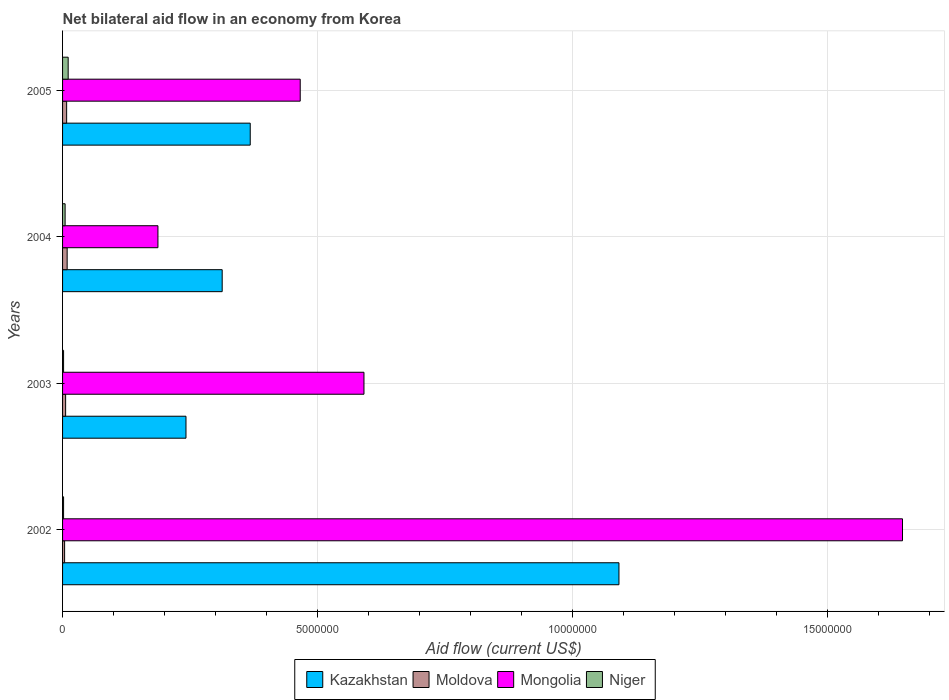How many different coloured bars are there?
Give a very brief answer. 4. How many groups of bars are there?
Offer a very short reply. 4. Across all years, what is the maximum net bilateral aid flow in Moldova?
Your answer should be compact. 9.00e+04. Across all years, what is the minimum net bilateral aid flow in Mongolia?
Offer a very short reply. 1.87e+06. What is the total net bilateral aid flow in Kazakhstan in the graph?
Provide a succinct answer. 2.01e+07. What is the difference between the net bilateral aid flow in Niger in 2003 and that in 2005?
Keep it short and to the point. -9.00e+04. What is the difference between the net bilateral aid flow in Niger in 2003 and the net bilateral aid flow in Kazakhstan in 2002?
Your response must be concise. -1.09e+07. What is the average net bilateral aid flow in Kazakhstan per year?
Provide a short and direct response. 5.04e+06. In the year 2005, what is the difference between the net bilateral aid flow in Niger and net bilateral aid flow in Kazakhstan?
Your response must be concise. -3.57e+06. What is the ratio of the net bilateral aid flow in Mongolia in 2002 to that in 2004?
Keep it short and to the point. 8.81. Is the net bilateral aid flow in Kazakhstan in 2004 less than that in 2005?
Your response must be concise. Yes. Is the difference between the net bilateral aid flow in Niger in 2003 and 2005 greater than the difference between the net bilateral aid flow in Kazakhstan in 2003 and 2005?
Provide a succinct answer. Yes. What is the difference between the highest and the second highest net bilateral aid flow in Moldova?
Provide a succinct answer. 10000. What is the difference between the highest and the lowest net bilateral aid flow in Mongolia?
Give a very brief answer. 1.46e+07. In how many years, is the net bilateral aid flow in Kazakhstan greater than the average net bilateral aid flow in Kazakhstan taken over all years?
Provide a short and direct response. 1. Is the sum of the net bilateral aid flow in Moldova in 2004 and 2005 greater than the maximum net bilateral aid flow in Kazakhstan across all years?
Give a very brief answer. No. Is it the case that in every year, the sum of the net bilateral aid flow in Moldova and net bilateral aid flow in Niger is greater than the sum of net bilateral aid flow in Mongolia and net bilateral aid flow in Kazakhstan?
Provide a succinct answer. No. What does the 1st bar from the top in 2003 represents?
Make the answer very short. Niger. What does the 1st bar from the bottom in 2002 represents?
Your answer should be very brief. Kazakhstan. How many bars are there?
Offer a terse response. 16. Are all the bars in the graph horizontal?
Your answer should be very brief. Yes. How many years are there in the graph?
Provide a succinct answer. 4. Are the values on the major ticks of X-axis written in scientific E-notation?
Provide a succinct answer. No. Does the graph contain grids?
Your answer should be very brief. Yes. How many legend labels are there?
Offer a terse response. 4. How are the legend labels stacked?
Your answer should be very brief. Horizontal. What is the title of the graph?
Make the answer very short. Net bilateral aid flow in an economy from Korea. Does "Iraq" appear as one of the legend labels in the graph?
Ensure brevity in your answer.  No. What is the Aid flow (current US$) of Kazakhstan in 2002?
Provide a short and direct response. 1.09e+07. What is the Aid flow (current US$) of Moldova in 2002?
Your response must be concise. 4.00e+04. What is the Aid flow (current US$) of Mongolia in 2002?
Your response must be concise. 1.65e+07. What is the Aid flow (current US$) in Niger in 2002?
Give a very brief answer. 2.00e+04. What is the Aid flow (current US$) of Kazakhstan in 2003?
Make the answer very short. 2.42e+06. What is the Aid flow (current US$) in Moldova in 2003?
Ensure brevity in your answer.  6.00e+04. What is the Aid flow (current US$) of Mongolia in 2003?
Offer a terse response. 5.91e+06. What is the Aid flow (current US$) of Niger in 2003?
Make the answer very short. 2.00e+04. What is the Aid flow (current US$) in Kazakhstan in 2004?
Make the answer very short. 3.13e+06. What is the Aid flow (current US$) in Mongolia in 2004?
Offer a very short reply. 1.87e+06. What is the Aid flow (current US$) in Niger in 2004?
Give a very brief answer. 5.00e+04. What is the Aid flow (current US$) of Kazakhstan in 2005?
Your response must be concise. 3.68e+06. What is the Aid flow (current US$) of Moldova in 2005?
Your answer should be very brief. 8.00e+04. What is the Aid flow (current US$) of Mongolia in 2005?
Make the answer very short. 4.66e+06. Across all years, what is the maximum Aid flow (current US$) in Kazakhstan?
Your answer should be compact. 1.09e+07. Across all years, what is the maximum Aid flow (current US$) of Moldova?
Keep it short and to the point. 9.00e+04. Across all years, what is the maximum Aid flow (current US$) of Mongolia?
Your response must be concise. 1.65e+07. Across all years, what is the maximum Aid flow (current US$) in Niger?
Offer a terse response. 1.10e+05. Across all years, what is the minimum Aid flow (current US$) in Kazakhstan?
Give a very brief answer. 2.42e+06. Across all years, what is the minimum Aid flow (current US$) in Mongolia?
Your response must be concise. 1.87e+06. Across all years, what is the minimum Aid flow (current US$) of Niger?
Your answer should be very brief. 2.00e+04. What is the total Aid flow (current US$) of Kazakhstan in the graph?
Ensure brevity in your answer.  2.01e+07. What is the total Aid flow (current US$) of Moldova in the graph?
Your response must be concise. 2.70e+05. What is the total Aid flow (current US$) of Mongolia in the graph?
Ensure brevity in your answer.  2.89e+07. What is the difference between the Aid flow (current US$) of Kazakhstan in 2002 and that in 2003?
Provide a succinct answer. 8.49e+06. What is the difference between the Aid flow (current US$) in Mongolia in 2002 and that in 2003?
Your answer should be very brief. 1.06e+07. What is the difference between the Aid flow (current US$) in Niger in 2002 and that in 2003?
Your response must be concise. 0. What is the difference between the Aid flow (current US$) in Kazakhstan in 2002 and that in 2004?
Your response must be concise. 7.78e+06. What is the difference between the Aid flow (current US$) of Moldova in 2002 and that in 2004?
Your response must be concise. -5.00e+04. What is the difference between the Aid flow (current US$) in Mongolia in 2002 and that in 2004?
Provide a short and direct response. 1.46e+07. What is the difference between the Aid flow (current US$) of Niger in 2002 and that in 2004?
Ensure brevity in your answer.  -3.00e+04. What is the difference between the Aid flow (current US$) in Kazakhstan in 2002 and that in 2005?
Your answer should be very brief. 7.23e+06. What is the difference between the Aid flow (current US$) of Mongolia in 2002 and that in 2005?
Provide a succinct answer. 1.18e+07. What is the difference between the Aid flow (current US$) in Niger in 2002 and that in 2005?
Provide a succinct answer. -9.00e+04. What is the difference between the Aid flow (current US$) in Kazakhstan in 2003 and that in 2004?
Offer a very short reply. -7.10e+05. What is the difference between the Aid flow (current US$) in Mongolia in 2003 and that in 2004?
Provide a short and direct response. 4.04e+06. What is the difference between the Aid flow (current US$) in Kazakhstan in 2003 and that in 2005?
Keep it short and to the point. -1.26e+06. What is the difference between the Aid flow (current US$) of Mongolia in 2003 and that in 2005?
Your answer should be very brief. 1.25e+06. What is the difference between the Aid flow (current US$) of Kazakhstan in 2004 and that in 2005?
Your answer should be compact. -5.50e+05. What is the difference between the Aid flow (current US$) in Mongolia in 2004 and that in 2005?
Provide a short and direct response. -2.79e+06. What is the difference between the Aid flow (current US$) of Niger in 2004 and that in 2005?
Offer a terse response. -6.00e+04. What is the difference between the Aid flow (current US$) of Kazakhstan in 2002 and the Aid flow (current US$) of Moldova in 2003?
Ensure brevity in your answer.  1.08e+07. What is the difference between the Aid flow (current US$) in Kazakhstan in 2002 and the Aid flow (current US$) in Mongolia in 2003?
Provide a short and direct response. 5.00e+06. What is the difference between the Aid flow (current US$) in Kazakhstan in 2002 and the Aid flow (current US$) in Niger in 2003?
Offer a very short reply. 1.09e+07. What is the difference between the Aid flow (current US$) of Moldova in 2002 and the Aid flow (current US$) of Mongolia in 2003?
Offer a very short reply. -5.87e+06. What is the difference between the Aid flow (current US$) in Mongolia in 2002 and the Aid flow (current US$) in Niger in 2003?
Give a very brief answer. 1.64e+07. What is the difference between the Aid flow (current US$) of Kazakhstan in 2002 and the Aid flow (current US$) of Moldova in 2004?
Ensure brevity in your answer.  1.08e+07. What is the difference between the Aid flow (current US$) in Kazakhstan in 2002 and the Aid flow (current US$) in Mongolia in 2004?
Provide a short and direct response. 9.04e+06. What is the difference between the Aid flow (current US$) of Kazakhstan in 2002 and the Aid flow (current US$) of Niger in 2004?
Provide a succinct answer. 1.09e+07. What is the difference between the Aid flow (current US$) in Moldova in 2002 and the Aid flow (current US$) in Mongolia in 2004?
Offer a terse response. -1.83e+06. What is the difference between the Aid flow (current US$) in Mongolia in 2002 and the Aid flow (current US$) in Niger in 2004?
Your answer should be very brief. 1.64e+07. What is the difference between the Aid flow (current US$) of Kazakhstan in 2002 and the Aid flow (current US$) of Moldova in 2005?
Your answer should be compact. 1.08e+07. What is the difference between the Aid flow (current US$) in Kazakhstan in 2002 and the Aid flow (current US$) in Mongolia in 2005?
Ensure brevity in your answer.  6.25e+06. What is the difference between the Aid flow (current US$) of Kazakhstan in 2002 and the Aid flow (current US$) of Niger in 2005?
Provide a short and direct response. 1.08e+07. What is the difference between the Aid flow (current US$) of Moldova in 2002 and the Aid flow (current US$) of Mongolia in 2005?
Provide a succinct answer. -4.62e+06. What is the difference between the Aid flow (current US$) in Mongolia in 2002 and the Aid flow (current US$) in Niger in 2005?
Offer a terse response. 1.64e+07. What is the difference between the Aid flow (current US$) in Kazakhstan in 2003 and the Aid flow (current US$) in Moldova in 2004?
Keep it short and to the point. 2.33e+06. What is the difference between the Aid flow (current US$) of Kazakhstan in 2003 and the Aid flow (current US$) of Niger in 2004?
Your answer should be compact. 2.37e+06. What is the difference between the Aid flow (current US$) of Moldova in 2003 and the Aid flow (current US$) of Mongolia in 2004?
Provide a succinct answer. -1.81e+06. What is the difference between the Aid flow (current US$) in Moldova in 2003 and the Aid flow (current US$) in Niger in 2004?
Your answer should be very brief. 10000. What is the difference between the Aid flow (current US$) of Mongolia in 2003 and the Aid flow (current US$) of Niger in 2004?
Give a very brief answer. 5.86e+06. What is the difference between the Aid flow (current US$) in Kazakhstan in 2003 and the Aid flow (current US$) in Moldova in 2005?
Your answer should be compact. 2.34e+06. What is the difference between the Aid flow (current US$) of Kazakhstan in 2003 and the Aid flow (current US$) of Mongolia in 2005?
Your answer should be very brief. -2.24e+06. What is the difference between the Aid flow (current US$) of Kazakhstan in 2003 and the Aid flow (current US$) of Niger in 2005?
Make the answer very short. 2.31e+06. What is the difference between the Aid flow (current US$) of Moldova in 2003 and the Aid flow (current US$) of Mongolia in 2005?
Offer a terse response. -4.60e+06. What is the difference between the Aid flow (current US$) in Mongolia in 2003 and the Aid flow (current US$) in Niger in 2005?
Provide a succinct answer. 5.80e+06. What is the difference between the Aid flow (current US$) of Kazakhstan in 2004 and the Aid flow (current US$) of Moldova in 2005?
Give a very brief answer. 3.05e+06. What is the difference between the Aid flow (current US$) in Kazakhstan in 2004 and the Aid flow (current US$) in Mongolia in 2005?
Your response must be concise. -1.53e+06. What is the difference between the Aid flow (current US$) in Kazakhstan in 2004 and the Aid flow (current US$) in Niger in 2005?
Make the answer very short. 3.02e+06. What is the difference between the Aid flow (current US$) in Moldova in 2004 and the Aid flow (current US$) in Mongolia in 2005?
Ensure brevity in your answer.  -4.57e+06. What is the difference between the Aid flow (current US$) of Moldova in 2004 and the Aid flow (current US$) of Niger in 2005?
Provide a succinct answer. -2.00e+04. What is the difference between the Aid flow (current US$) of Mongolia in 2004 and the Aid flow (current US$) of Niger in 2005?
Make the answer very short. 1.76e+06. What is the average Aid flow (current US$) of Kazakhstan per year?
Make the answer very short. 5.04e+06. What is the average Aid flow (current US$) of Moldova per year?
Your response must be concise. 6.75e+04. What is the average Aid flow (current US$) in Mongolia per year?
Your answer should be very brief. 7.23e+06. What is the average Aid flow (current US$) in Niger per year?
Your response must be concise. 5.00e+04. In the year 2002, what is the difference between the Aid flow (current US$) of Kazakhstan and Aid flow (current US$) of Moldova?
Provide a succinct answer. 1.09e+07. In the year 2002, what is the difference between the Aid flow (current US$) of Kazakhstan and Aid flow (current US$) of Mongolia?
Provide a short and direct response. -5.56e+06. In the year 2002, what is the difference between the Aid flow (current US$) of Kazakhstan and Aid flow (current US$) of Niger?
Give a very brief answer. 1.09e+07. In the year 2002, what is the difference between the Aid flow (current US$) in Moldova and Aid flow (current US$) in Mongolia?
Provide a succinct answer. -1.64e+07. In the year 2002, what is the difference between the Aid flow (current US$) in Moldova and Aid flow (current US$) in Niger?
Ensure brevity in your answer.  2.00e+04. In the year 2002, what is the difference between the Aid flow (current US$) of Mongolia and Aid flow (current US$) of Niger?
Your answer should be very brief. 1.64e+07. In the year 2003, what is the difference between the Aid flow (current US$) of Kazakhstan and Aid flow (current US$) of Moldova?
Offer a very short reply. 2.36e+06. In the year 2003, what is the difference between the Aid flow (current US$) in Kazakhstan and Aid flow (current US$) in Mongolia?
Keep it short and to the point. -3.49e+06. In the year 2003, what is the difference between the Aid flow (current US$) of Kazakhstan and Aid flow (current US$) of Niger?
Keep it short and to the point. 2.40e+06. In the year 2003, what is the difference between the Aid flow (current US$) of Moldova and Aid flow (current US$) of Mongolia?
Ensure brevity in your answer.  -5.85e+06. In the year 2003, what is the difference between the Aid flow (current US$) in Mongolia and Aid flow (current US$) in Niger?
Offer a very short reply. 5.89e+06. In the year 2004, what is the difference between the Aid flow (current US$) of Kazakhstan and Aid flow (current US$) of Moldova?
Ensure brevity in your answer.  3.04e+06. In the year 2004, what is the difference between the Aid flow (current US$) of Kazakhstan and Aid flow (current US$) of Mongolia?
Keep it short and to the point. 1.26e+06. In the year 2004, what is the difference between the Aid flow (current US$) in Kazakhstan and Aid flow (current US$) in Niger?
Ensure brevity in your answer.  3.08e+06. In the year 2004, what is the difference between the Aid flow (current US$) of Moldova and Aid flow (current US$) of Mongolia?
Offer a very short reply. -1.78e+06. In the year 2004, what is the difference between the Aid flow (current US$) of Moldova and Aid flow (current US$) of Niger?
Your answer should be very brief. 4.00e+04. In the year 2004, what is the difference between the Aid flow (current US$) of Mongolia and Aid flow (current US$) of Niger?
Offer a very short reply. 1.82e+06. In the year 2005, what is the difference between the Aid flow (current US$) of Kazakhstan and Aid flow (current US$) of Moldova?
Offer a terse response. 3.60e+06. In the year 2005, what is the difference between the Aid flow (current US$) of Kazakhstan and Aid flow (current US$) of Mongolia?
Keep it short and to the point. -9.80e+05. In the year 2005, what is the difference between the Aid flow (current US$) of Kazakhstan and Aid flow (current US$) of Niger?
Provide a succinct answer. 3.57e+06. In the year 2005, what is the difference between the Aid flow (current US$) of Moldova and Aid flow (current US$) of Mongolia?
Ensure brevity in your answer.  -4.58e+06. In the year 2005, what is the difference between the Aid flow (current US$) in Mongolia and Aid flow (current US$) in Niger?
Offer a terse response. 4.55e+06. What is the ratio of the Aid flow (current US$) of Kazakhstan in 2002 to that in 2003?
Provide a succinct answer. 4.51. What is the ratio of the Aid flow (current US$) in Moldova in 2002 to that in 2003?
Offer a very short reply. 0.67. What is the ratio of the Aid flow (current US$) in Mongolia in 2002 to that in 2003?
Keep it short and to the point. 2.79. What is the ratio of the Aid flow (current US$) of Niger in 2002 to that in 2003?
Keep it short and to the point. 1. What is the ratio of the Aid flow (current US$) of Kazakhstan in 2002 to that in 2004?
Provide a short and direct response. 3.49. What is the ratio of the Aid flow (current US$) of Moldova in 2002 to that in 2004?
Offer a terse response. 0.44. What is the ratio of the Aid flow (current US$) in Mongolia in 2002 to that in 2004?
Provide a short and direct response. 8.81. What is the ratio of the Aid flow (current US$) in Kazakhstan in 2002 to that in 2005?
Keep it short and to the point. 2.96. What is the ratio of the Aid flow (current US$) in Mongolia in 2002 to that in 2005?
Offer a terse response. 3.53. What is the ratio of the Aid flow (current US$) of Niger in 2002 to that in 2005?
Make the answer very short. 0.18. What is the ratio of the Aid flow (current US$) of Kazakhstan in 2003 to that in 2004?
Keep it short and to the point. 0.77. What is the ratio of the Aid flow (current US$) of Moldova in 2003 to that in 2004?
Make the answer very short. 0.67. What is the ratio of the Aid flow (current US$) in Mongolia in 2003 to that in 2004?
Give a very brief answer. 3.16. What is the ratio of the Aid flow (current US$) of Niger in 2003 to that in 2004?
Give a very brief answer. 0.4. What is the ratio of the Aid flow (current US$) of Kazakhstan in 2003 to that in 2005?
Provide a short and direct response. 0.66. What is the ratio of the Aid flow (current US$) of Mongolia in 2003 to that in 2005?
Provide a short and direct response. 1.27. What is the ratio of the Aid flow (current US$) in Niger in 2003 to that in 2005?
Your answer should be compact. 0.18. What is the ratio of the Aid flow (current US$) of Kazakhstan in 2004 to that in 2005?
Give a very brief answer. 0.85. What is the ratio of the Aid flow (current US$) in Mongolia in 2004 to that in 2005?
Give a very brief answer. 0.4. What is the ratio of the Aid flow (current US$) of Niger in 2004 to that in 2005?
Provide a short and direct response. 0.45. What is the difference between the highest and the second highest Aid flow (current US$) of Kazakhstan?
Offer a terse response. 7.23e+06. What is the difference between the highest and the second highest Aid flow (current US$) of Moldova?
Ensure brevity in your answer.  10000. What is the difference between the highest and the second highest Aid flow (current US$) in Mongolia?
Make the answer very short. 1.06e+07. What is the difference between the highest and the second highest Aid flow (current US$) of Niger?
Ensure brevity in your answer.  6.00e+04. What is the difference between the highest and the lowest Aid flow (current US$) of Kazakhstan?
Offer a terse response. 8.49e+06. What is the difference between the highest and the lowest Aid flow (current US$) of Moldova?
Ensure brevity in your answer.  5.00e+04. What is the difference between the highest and the lowest Aid flow (current US$) of Mongolia?
Keep it short and to the point. 1.46e+07. What is the difference between the highest and the lowest Aid flow (current US$) in Niger?
Make the answer very short. 9.00e+04. 